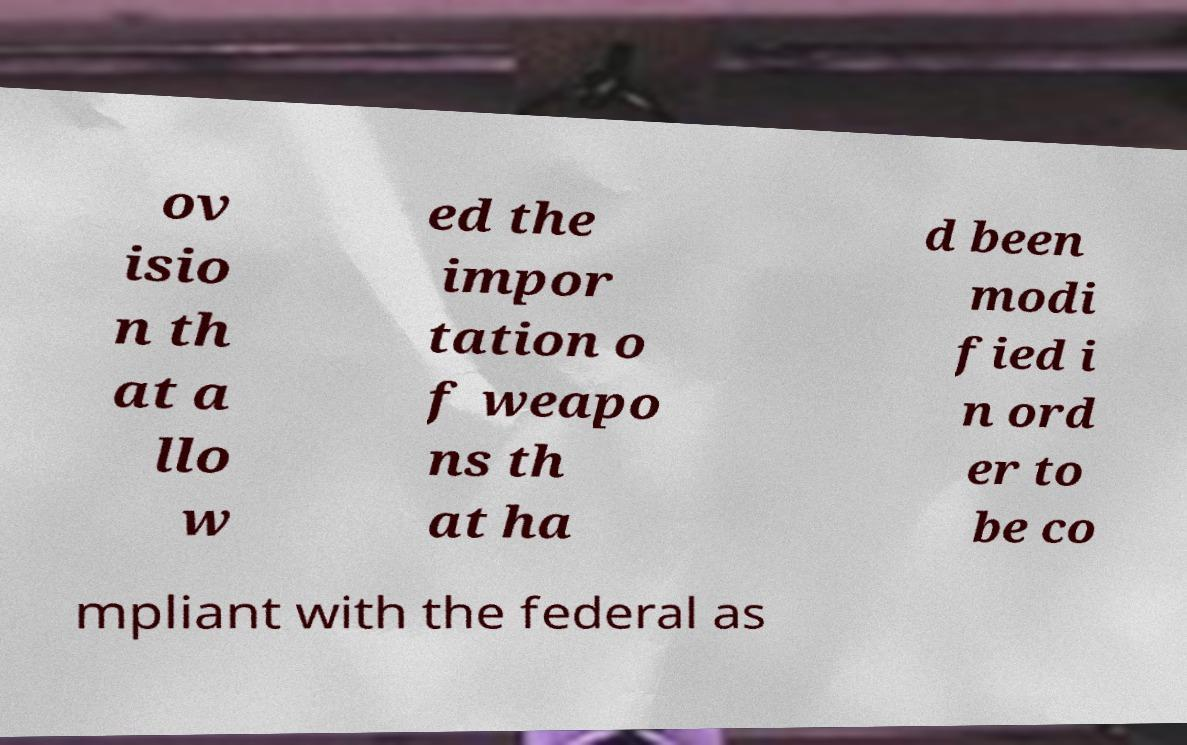Can you read and provide the text displayed in the image?This photo seems to have some interesting text. Can you extract and type it out for me? ov isio n th at a llo w ed the impor tation o f weapo ns th at ha d been modi fied i n ord er to be co mpliant with the federal as 